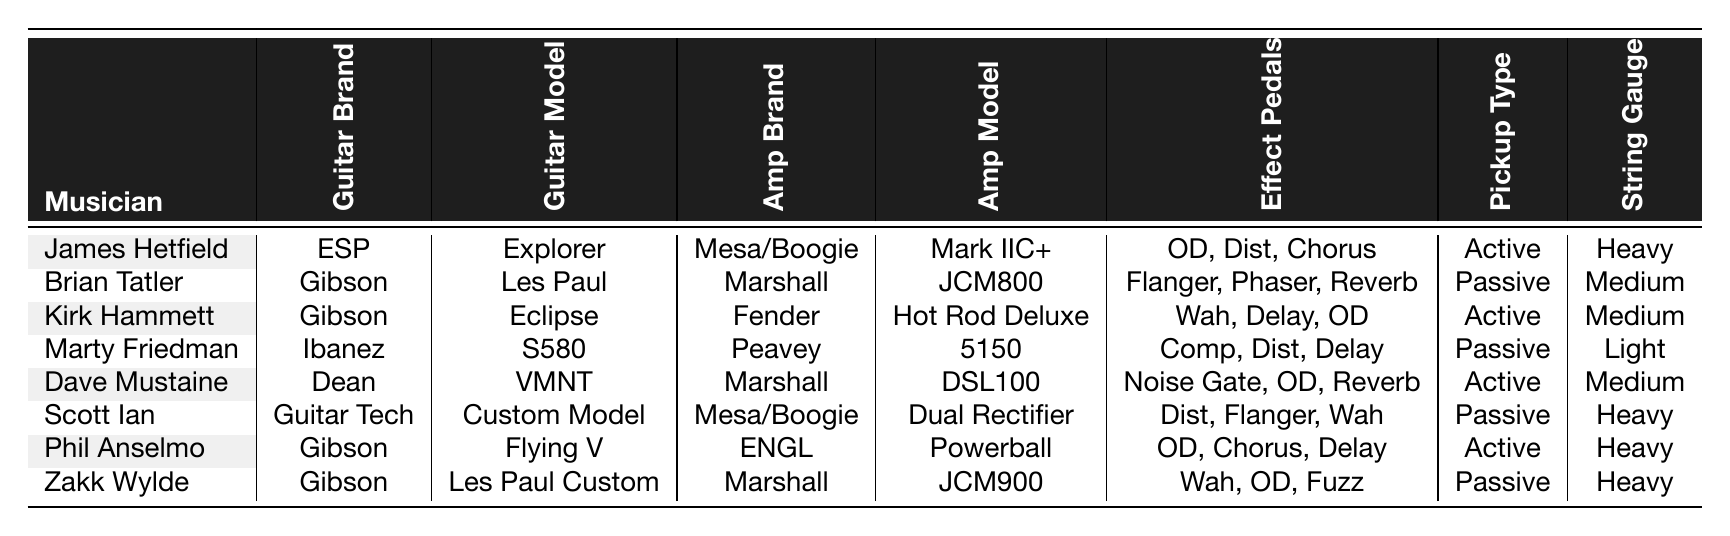What is the guitar brand used by Dave Mustaine? The table directly shows that Dave Mustaine uses a Dean guitar brand.
Answer: Dean Which musician uses a Gibson guitar with a Passive pickup type? The table lists multiple musicians with Gibson guitars, and I can see that Brian Tatler and Zakk Wylde both have Passive pickups.
Answer: Brian Tatler and Zakk Wylde What is the most common amp brand among the musicians in the table? I can check the amp brands listed for each musician: Mesa/Boogie (2), Marshall (4), Fender (1), Peavey (1), and ENGL (1). The highest count is for Marshall, with a total of 4 musicians using it.
Answer: Marshall Do any musicians use Heavy string gauge with Passive pickups? Reviewing the table, I find that Scott Ian and Zakk Wylde use Heavy string gauge, and both have Passive pickups. So, the answer is yes.
Answer: Yes Which musician has the most effect pedals listed? The musicians have different effect pedals listed. Both James Hetfield and Phil Anselmo have 3 effect pedals, so they are the only ones with the highest count.
Answer: James Hetfield and Phil Anselmo What is the average string gauge of the musicians listed? The string gauges are Heavy (4), Medium (3), and Light (1). Converting these to a numerical scale where Heavy=1, Medium=2, Light=3, the sum is (1*4 + 2*3 + 3*1) = 4 + 6 + 3 = 13. There are 8 musicians, so the average is 13/8 = 1.625. Based on our string gauge system, it most closely represents a Medium gauge.
Answer: Medium Is it true that all musicians play with Active pickups? Checking the table, I see that both Marty Friedman and Zakk Wylde play with Passive pickups, so the statement is false.
Answer: No How many musicians use Mesa/Boogie amps? The table lists James Hetfield and Scott Ian as the two musicians using Mesa/Boogie amps.
Answer: 2 